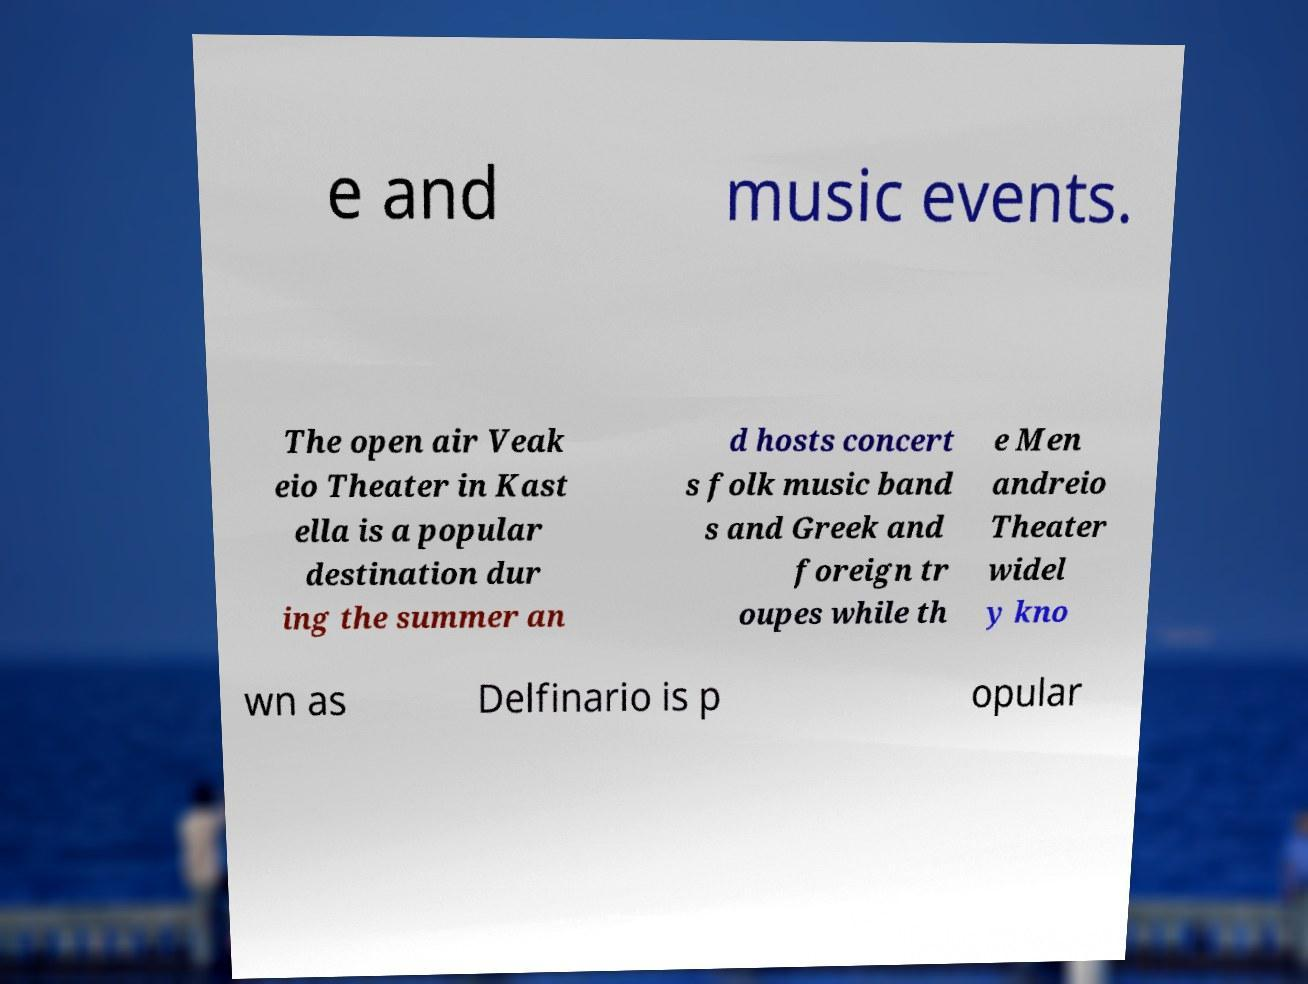Can you read and provide the text displayed in the image?This photo seems to have some interesting text. Can you extract and type it out for me? e and music events. The open air Veak eio Theater in Kast ella is a popular destination dur ing the summer an d hosts concert s folk music band s and Greek and foreign tr oupes while th e Men andreio Theater widel y kno wn as Delfinario is p opular 